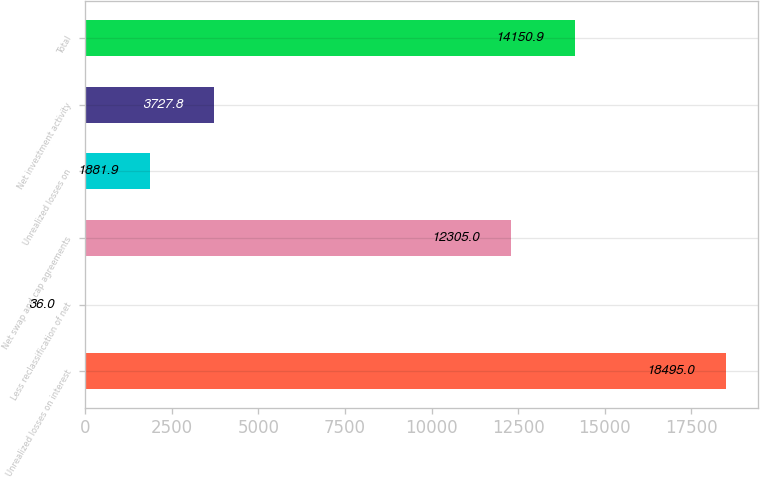Convert chart. <chart><loc_0><loc_0><loc_500><loc_500><bar_chart><fcel>Unrealized losses on interest<fcel>Less reclassification of net<fcel>Net swap and cap agreements<fcel>Unrealized losses on<fcel>Net investment activity<fcel>Total<nl><fcel>18495<fcel>36<fcel>12305<fcel>1881.9<fcel>3727.8<fcel>14150.9<nl></chart> 